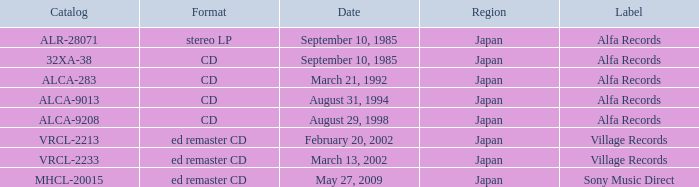Which Label was cataloged as alca-9013? Alfa Records. 